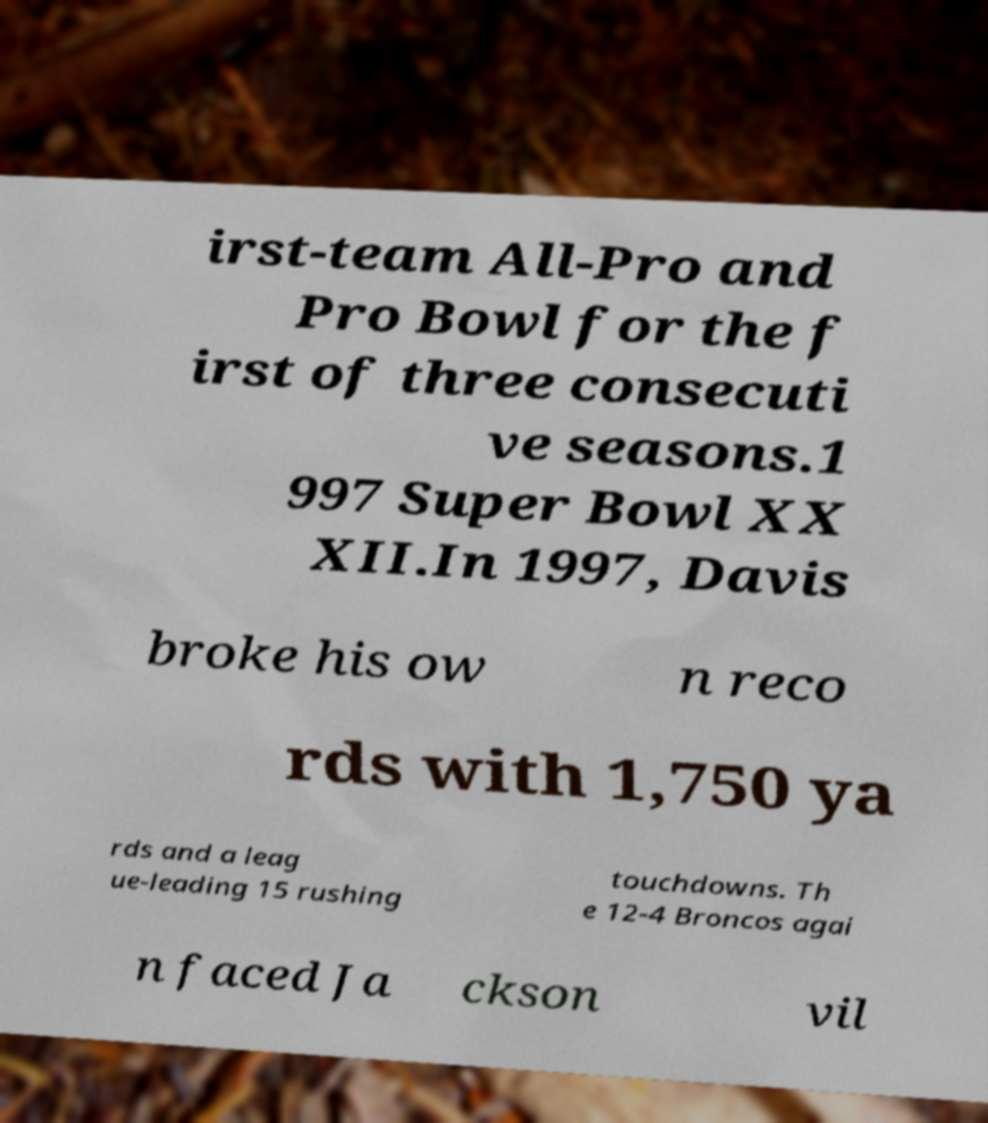Can you read and provide the text displayed in the image?This photo seems to have some interesting text. Can you extract and type it out for me? irst-team All-Pro and Pro Bowl for the f irst of three consecuti ve seasons.1 997 Super Bowl XX XII.In 1997, Davis broke his ow n reco rds with 1,750 ya rds and a leag ue-leading 15 rushing touchdowns. Th e 12-4 Broncos agai n faced Ja ckson vil 